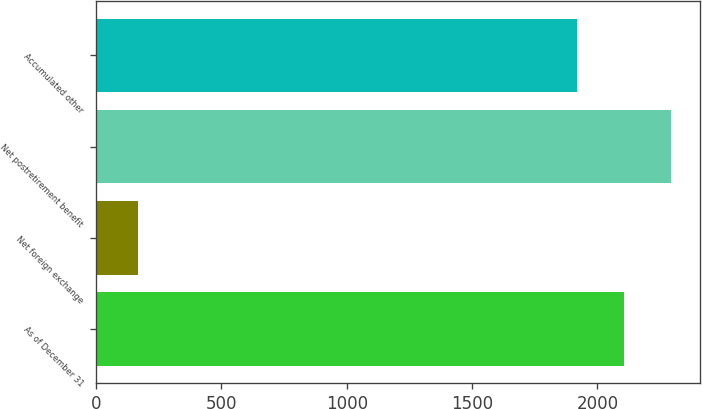Convert chart. <chart><loc_0><loc_0><loc_500><loc_500><bar_chart><fcel>As of December 31<fcel>Net foreign exchange<fcel>Net postretirement benefit<fcel>Accumulated other<nl><fcel>2106.3<fcel>168<fcel>2295.6<fcel>1917<nl></chart> 